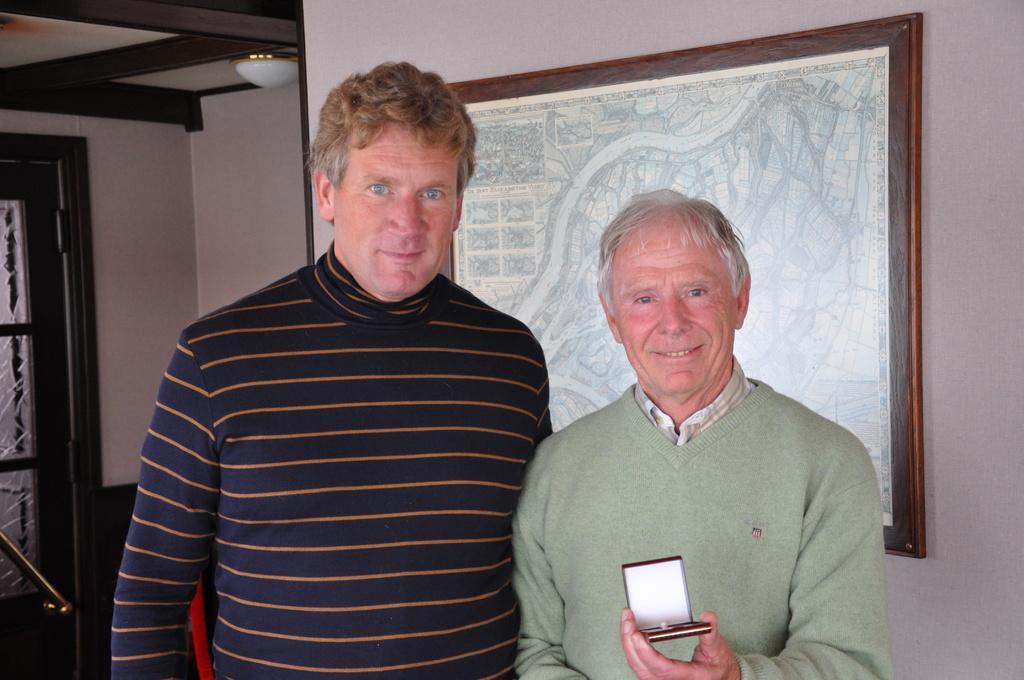In one or two sentences, can you explain what this image depicts? This picture is clicked inside the room. On the right there is a man wearing a sweater, smiling, holding a box and standing. On the left there is a person wearing t-shirt, smiling and standing. In the background we can see the wall, door, roof and the light and we can see a frame hanging on the wall containing the depictions of some objects. 